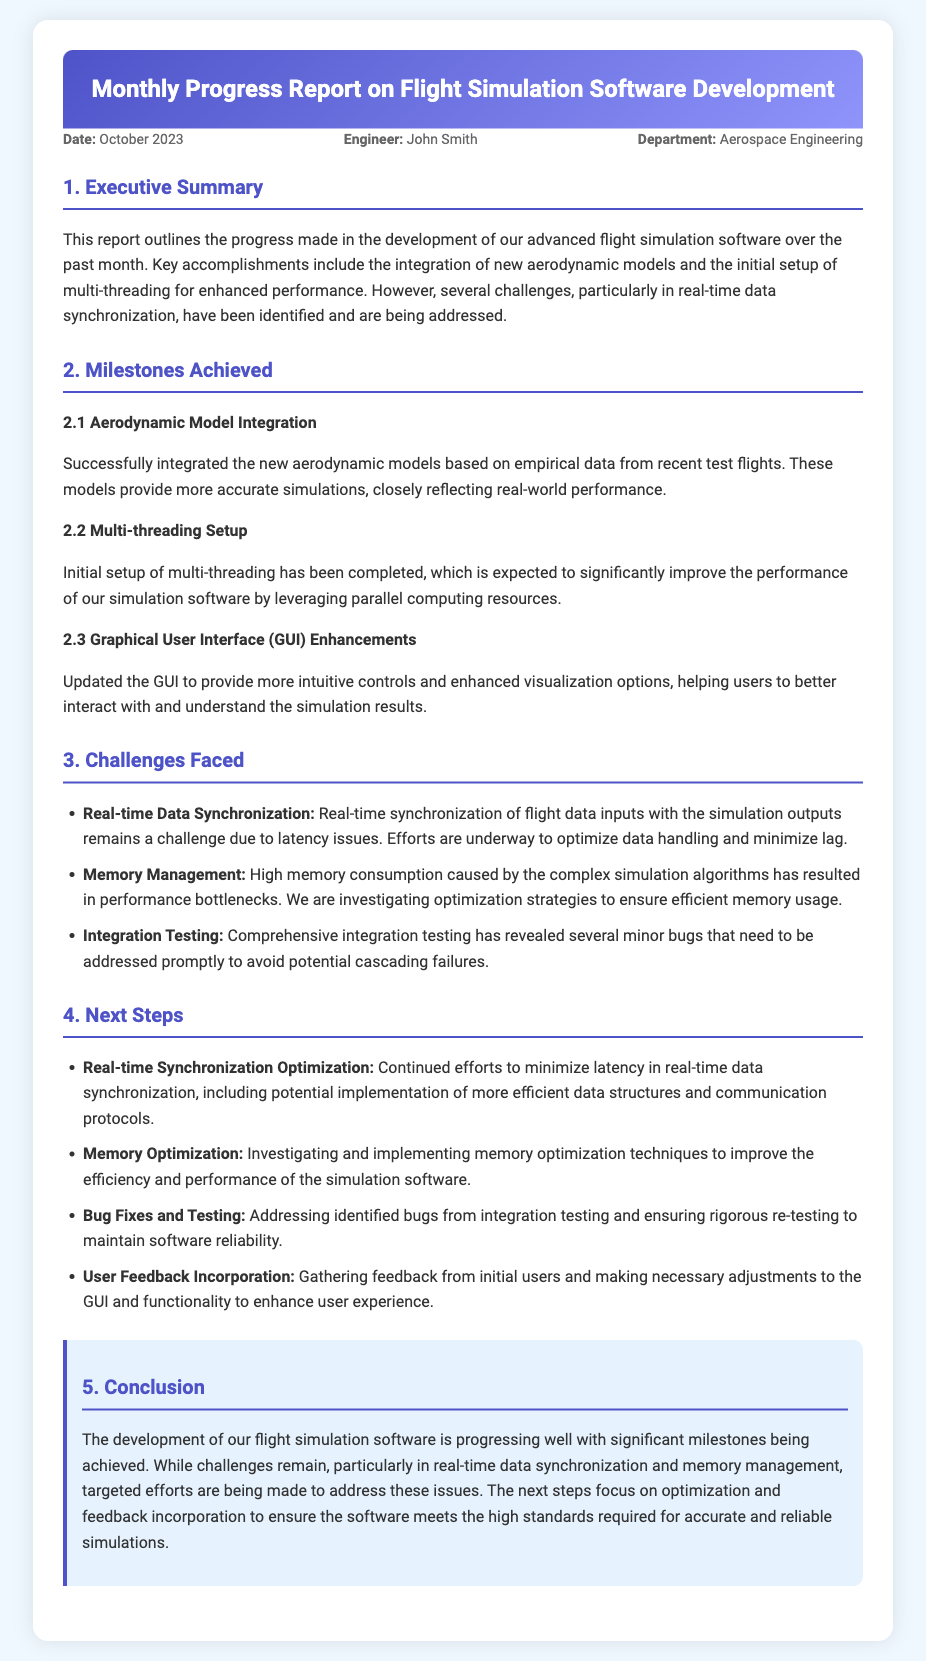What is the date of the report? The date of the report is mentioned in the meta section of the document.
Answer: October 2023 Who is the engineer responsible for this report? The engineer's name is provided in the meta section.
Answer: John Smith What major milestone was achieved related to aerodynamic models? The document describes a specific achievement in the milestones section regarding aerodynamic models.
Answer: Integrated new aerodynamic models What challenge related to memory management was faced? A specific challenge pertaining to memory management is outlined in the challenges section.
Answer: High memory consumption What is one of the next steps identified in the report? The next steps are listed in the corresponding section of the document.
Answer: Real-time Synchronization Optimization What kind of models were successfully integrated? The document discusses the type of models that have been integrated in the milestones section.
Answer: Aerodynamic models What has been improved in the Graphical User Interface? The document mentions enhancements made to the GUI in the milestones section.
Answer: Intuitive controls and enhanced visualization options How many challenges are listed in the report? The total number of challenges can be counted from the list in the challenges section.
Answer: Three 